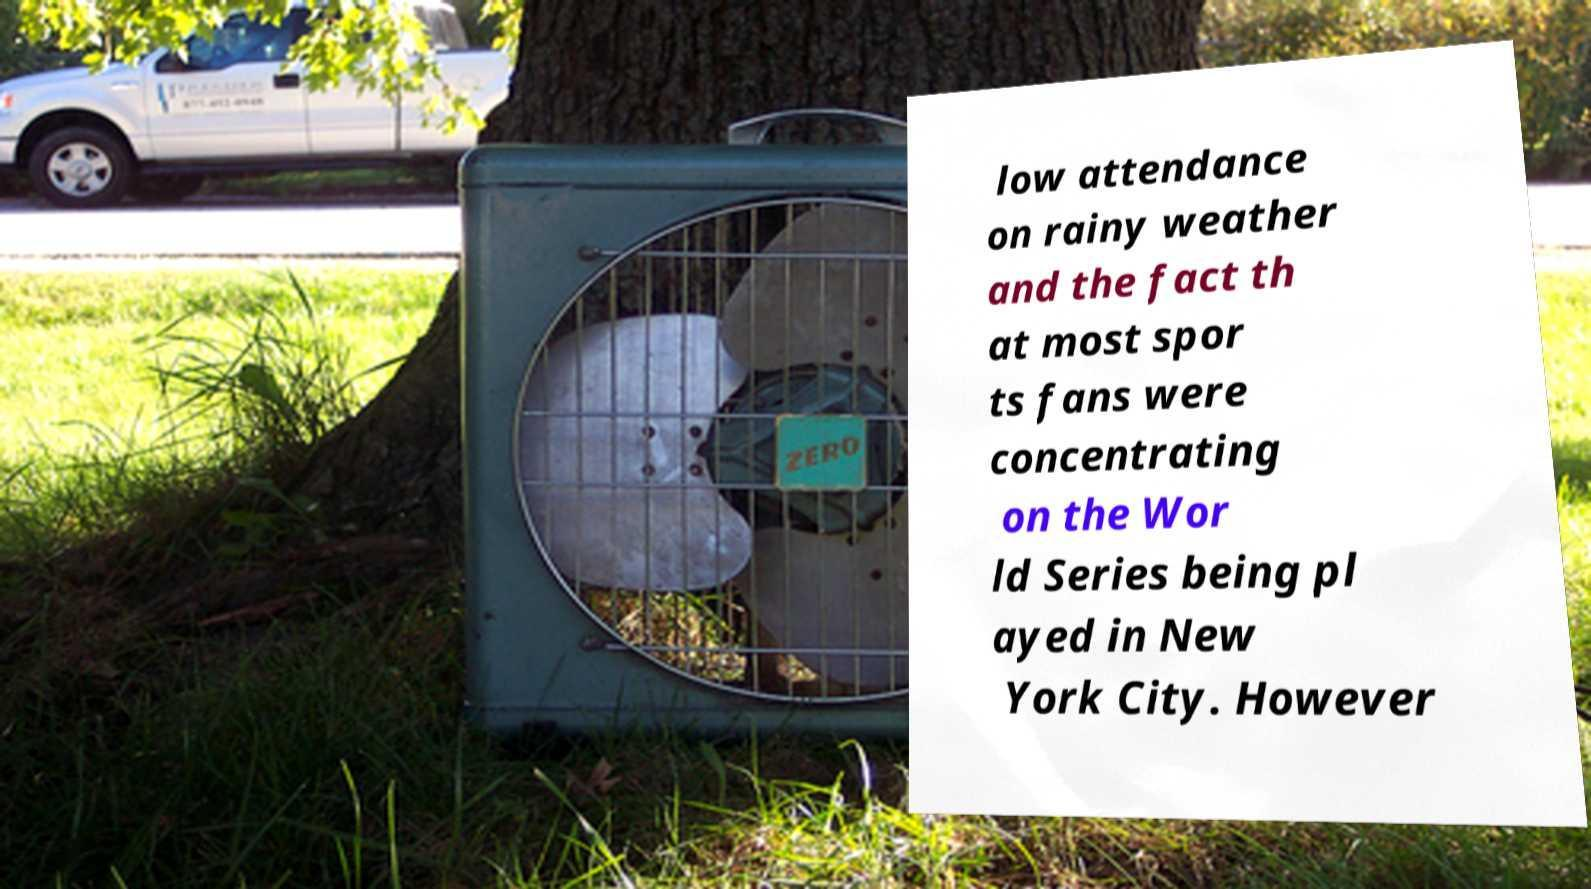Please read and relay the text visible in this image. What does it say? low attendance on rainy weather and the fact th at most spor ts fans were concentrating on the Wor ld Series being pl ayed in New York City. However 